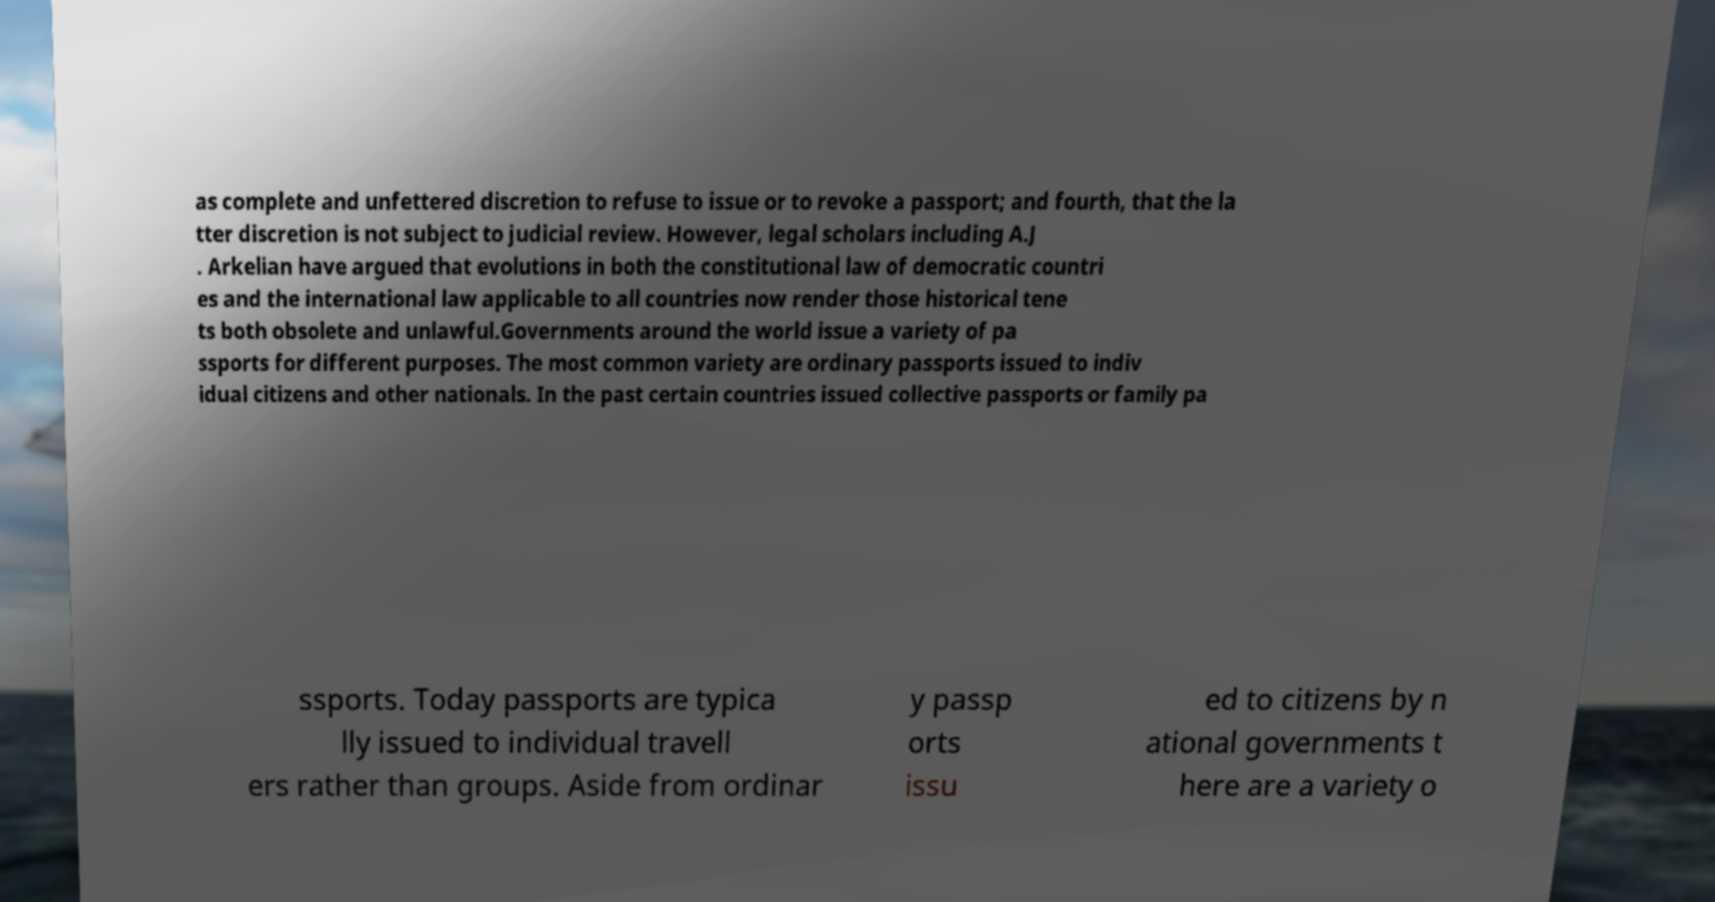Please read and relay the text visible in this image. What does it say? as complete and unfettered discretion to refuse to issue or to revoke a passport; and fourth, that the la tter discretion is not subject to judicial review. However, legal scholars including A.J . Arkelian have argued that evolutions in both the constitutional law of democratic countri es and the international law applicable to all countries now render those historical tene ts both obsolete and unlawful.Governments around the world issue a variety of pa ssports for different purposes. The most common variety are ordinary passports issued to indiv idual citizens and other nationals. In the past certain countries issued collective passports or family pa ssports. Today passports are typica lly issued to individual travell ers rather than groups. Aside from ordinar y passp orts issu ed to citizens by n ational governments t here are a variety o 